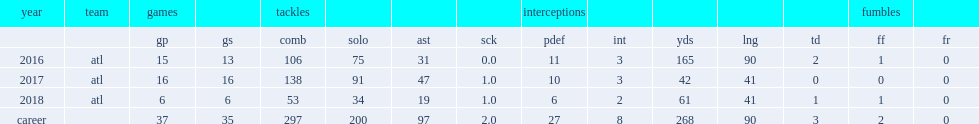Parse the table in full. {'header': ['year', 'team', 'games', '', 'tackles', '', '', '', 'interceptions', '', '', '', '', 'fumbles', ''], 'rows': [['', '', 'gp', 'gs', 'comb', 'solo', 'ast', 'sck', 'pdef', 'int', 'yds', 'lng', 'td', 'ff', 'fr'], ['2016', 'atl', '15', '13', '106', '75', '31', '0.0', '11', '3', '165', '90', '2', '1', '0'], ['2017', 'atl', '16', '16', '138', '91', '47', '1.0', '10', '3', '42', '41', '0', '0', '0'], ['2018', 'atl', '6', '6', '53', '34', '19', '1.0', '6', '2', '61', '41', '1', '1', '0'], ['career', '', '37', '35', '297', '200', '97', '2.0', '27', '8', '268', '90', '3', '2', '0']]} How many combined tackles did jones get in 2017? 138.0. 